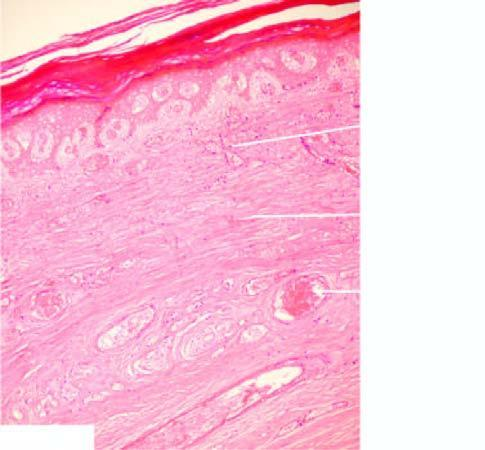what does microscopy show of the skin, muscle and other soft tissue, and thrombsed vessels?
Answer the question using a single word or phrase. Coagulativenecrosis vessels 